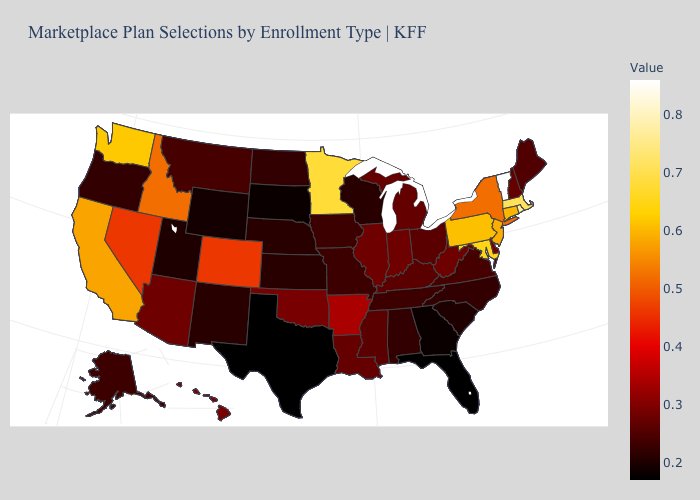Does Hawaii have the highest value in the West?
Quick response, please. No. Among the states that border Arkansas , which have the highest value?
Write a very short answer. Oklahoma. Does Alaska have a lower value than Arkansas?
Give a very brief answer. Yes. 